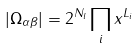<formula> <loc_0><loc_0><loc_500><loc_500>| \Omega _ { \alpha \beta } | = 2 ^ { N _ { l } } \prod _ { i } x ^ { L _ { i } }</formula> 